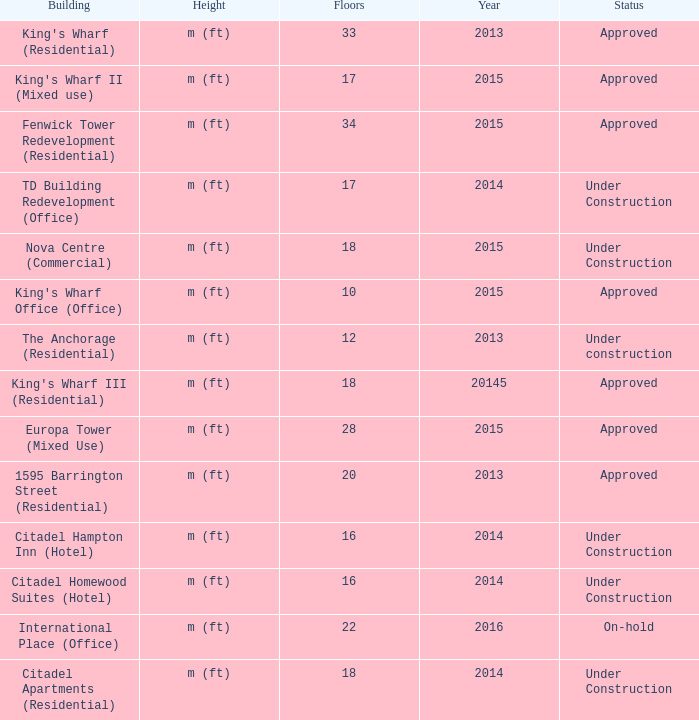What building shows 2013 and has more than 20 floors? King's Wharf (Residential). 